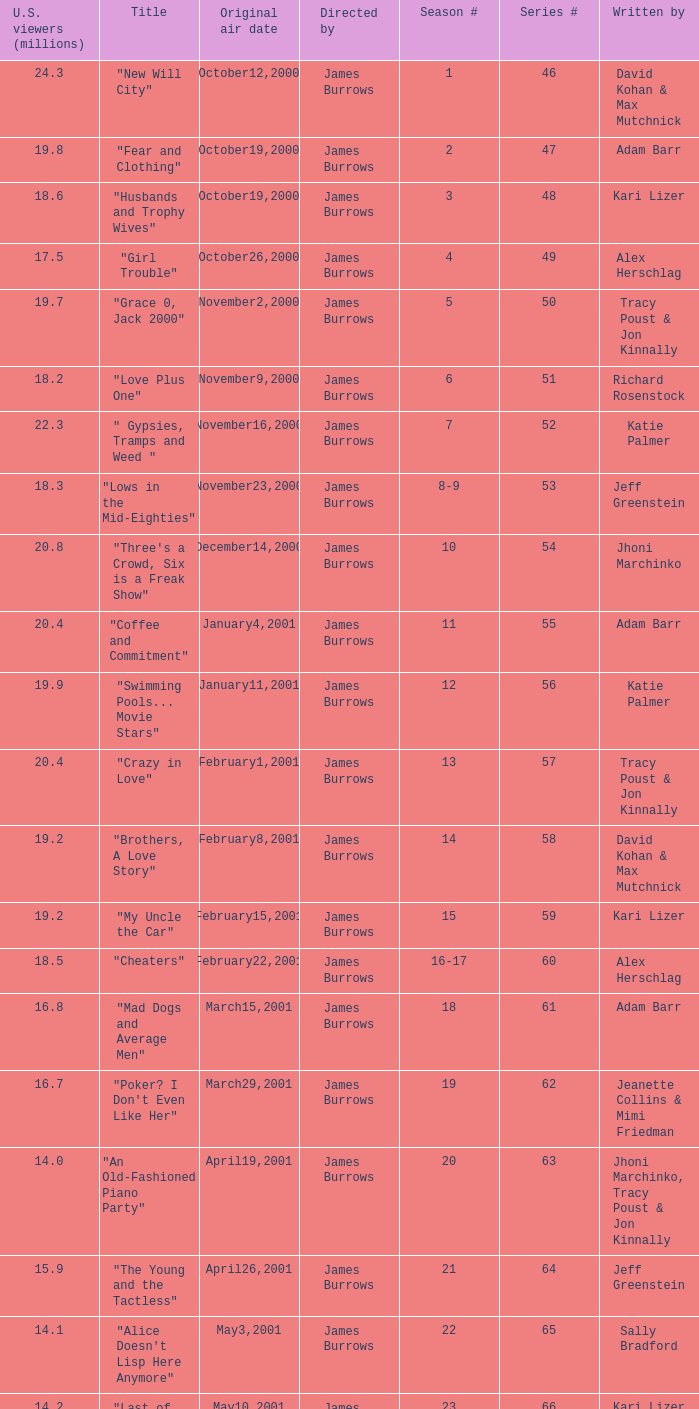Who wrote episode 23 in the season? Kari Lizer. 